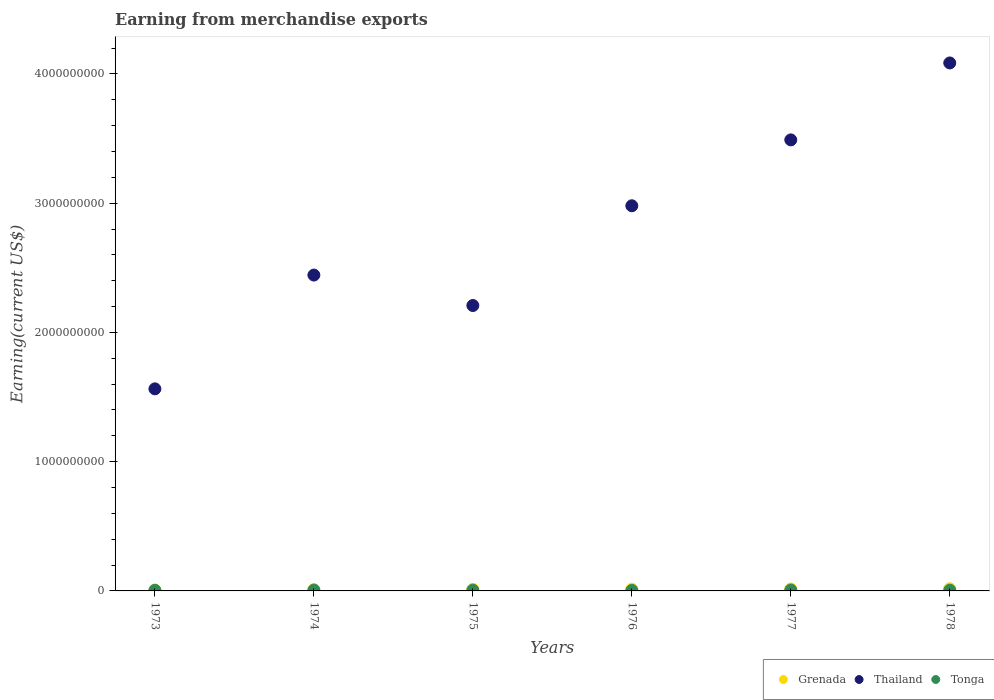How many different coloured dotlines are there?
Provide a short and direct response. 3. What is the amount earned from merchandise exports in Grenada in 1973?
Make the answer very short. 7.38e+06. Across all years, what is the maximum amount earned from merchandise exports in Grenada?
Give a very brief answer. 1.69e+07. Across all years, what is the minimum amount earned from merchandise exports in Grenada?
Provide a succinct answer. 7.38e+06. In which year was the amount earned from merchandise exports in Grenada maximum?
Keep it short and to the point. 1978. In which year was the amount earned from merchandise exports in Thailand minimum?
Your answer should be very brief. 1973. What is the total amount earned from merchandise exports in Grenada in the graph?
Give a very brief answer. 7.35e+07. What is the difference between the amount earned from merchandise exports in Tonga in 1976 and that in 1977?
Keep it short and to the point. -3.11e+06. What is the difference between the amount earned from merchandise exports in Tonga in 1973 and the amount earned from merchandise exports in Thailand in 1976?
Provide a short and direct response. -2.98e+09. What is the average amount earned from merchandise exports in Thailand per year?
Your answer should be very brief. 2.80e+09. In the year 1975, what is the difference between the amount earned from merchandise exports in Thailand and amount earned from merchandise exports in Grenada?
Your answer should be very brief. 2.20e+09. What is the ratio of the amount earned from merchandise exports in Tonga in 1975 to that in 1978?
Provide a succinct answer. 1.07. Is the difference between the amount earned from merchandise exports in Thailand in 1974 and 1976 greater than the difference between the amount earned from merchandise exports in Grenada in 1974 and 1976?
Provide a short and direct response. No. What is the difference between the highest and the second highest amount earned from merchandise exports in Thailand?
Give a very brief answer. 5.95e+08. What is the difference between the highest and the lowest amount earned from merchandise exports in Tonga?
Offer a very short reply. 3.11e+06. In how many years, is the amount earned from merchandise exports in Grenada greater than the average amount earned from merchandise exports in Grenada taken over all years?
Offer a very short reply. 4. Is it the case that in every year, the sum of the amount earned from merchandise exports in Grenada and amount earned from merchandise exports in Thailand  is greater than the amount earned from merchandise exports in Tonga?
Ensure brevity in your answer.  Yes. Does the amount earned from merchandise exports in Tonga monotonically increase over the years?
Offer a terse response. No. Is the amount earned from merchandise exports in Thailand strictly less than the amount earned from merchandise exports in Grenada over the years?
Provide a short and direct response. No. How many years are there in the graph?
Provide a succinct answer. 6. What is the difference between two consecutive major ticks on the Y-axis?
Your answer should be compact. 1.00e+09. Does the graph contain grids?
Offer a terse response. No. How are the legend labels stacked?
Ensure brevity in your answer.  Horizontal. What is the title of the graph?
Provide a succinct answer. Earning from merchandise exports. What is the label or title of the Y-axis?
Your answer should be very brief. Earning(current US$). What is the Earning(current US$) in Grenada in 1973?
Offer a very short reply. 7.38e+06. What is the Earning(current US$) of Thailand in 1973?
Your response must be concise. 1.56e+09. What is the Earning(current US$) in Tonga in 1973?
Keep it short and to the point. 4.54e+06. What is the Earning(current US$) of Grenada in 1974?
Provide a succinct answer. 9.50e+06. What is the Earning(current US$) of Thailand in 1974?
Keep it short and to the point. 2.44e+09. What is the Earning(current US$) in Tonga in 1974?
Ensure brevity in your answer.  6.61e+06. What is the Earning(current US$) in Grenada in 1975?
Your answer should be compact. 1.24e+07. What is the Earning(current US$) of Thailand in 1975?
Keep it short and to the point. 2.21e+09. What is the Earning(current US$) in Tonga in 1975?
Your answer should be very brief. 5.83e+06. What is the Earning(current US$) in Grenada in 1976?
Your response must be concise. 1.30e+07. What is the Earning(current US$) in Thailand in 1976?
Give a very brief answer. 2.98e+09. What is the Earning(current US$) in Tonga in 1976?
Keep it short and to the point. 3.93e+06. What is the Earning(current US$) in Grenada in 1977?
Ensure brevity in your answer.  1.44e+07. What is the Earning(current US$) in Thailand in 1977?
Give a very brief answer. 3.49e+09. What is the Earning(current US$) in Tonga in 1977?
Provide a short and direct response. 7.04e+06. What is the Earning(current US$) in Grenada in 1978?
Your answer should be compact. 1.69e+07. What is the Earning(current US$) of Thailand in 1978?
Provide a short and direct response. 4.09e+09. What is the Earning(current US$) in Tonga in 1978?
Offer a very short reply. 5.45e+06. Across all years, what is the maximum Earning(current US$) in Grenada?
Your response must be concise. 1.69e+07. Across all years, what is the maximum Earning(current US$) of Thailand?
Offer a very short reply. 4.09e+09. Across all years, what is the maximum Earning(current US$) of Tonga?
Ensure brevity in your answer.  7.04e+06. Across all years, what is the minimum Earning(current US$) of Grenada?
Offer a terse response. 7.38e+06. Across all years, what is the minimum Earning(current US$) of Thailand?
Provide a short and direct response. 1.56e+09. Across all years, what is the minimum Earning(current US$) of Tonga?
Your answer should be compact. 3.93e+06. What is the total Earning(current US$) of Grenada in the graph?
Provide a succinct answer. 7.35e+07. What is the total Earning(current US$) in Thailand in the graph?
Ensure brevity in your answer.  1.68e+1. What is the total Earning(current US$) of Tonga in the graph?
Keep it short and to the point. 3.34e+07. What is the difference between the Earning(current US$) of Grenada in 1973 and that in 1974?
Give a very brief answer. -2.12e+06. What is the difference between the Earning(current US$) in Thailand in 1973 and that in 1974?
Ensure brevity in your answer.  -8.80e+08. What is the difference between the Earning(current US$) in Tonga in 1973 and that in 1974?
Keep it short and to the point. -2.07e+06. What is the difference between the Earning(current US$) in Grenada in 1973 and that in 1975?
Your response must be concise. -5.02e+06. What is the difference between the Earning(current US$) in Thailand in 1973 and that in 1975?
Your answer should be very brief. -6.45e+08. What is the difference between the Earning(current US$) in Tonga in 1973 and that in 1975?
Provide a short and direct response. -1.28e+06. What is the difference between the Earning(current US$) of Grenada in 1973 and that in 1976?
Offer a very short reply. -5.58e+06. What is the difference between the Earning(current US$) in Thailand in 1973 and that in 1976?
Your response must be concise. -1.42e+09. What is the difference between the Earning(current US$) of Tonga in 1973 and that in 1976?
Offer a terse response. 6.11e+05. What is the difference between the Earning(current US$) of Grenada in 1973 and that in 1977?
Give a very brief answer. -6.97e+06. What is the difference between the Earning(current US$) of Thailand in 1973 and that in 1977?
Offer a terse response. -1.93e+09. What is the difference between the Earning(current US$) in Tonga in 1973 and that in 1977?
Your response must be concise. -2.50e+06. What is the difference between the Earning(current US$) of Grenada in 1973 and that in 1978?
Provide a short and direct response. -9.50e+06. What is the difference between the Earning(current US$) in Thailand in 1973 and that in 1978?
Offer a terse response. -2.52e+09. What is the difference between the Earning(current US$) of Tonga in 1973 and that in 1978?
Provide a short and direct response. -9.10e+05. What is the difference between the Earning(current US$) in Grenada in 1974 and that in 1975?
Your response must be concise. -2.90e+06. What is the difference between the Earning(current US$) of Thailand in 1974 and that in 1975?
Your answer should be very brief. 2.36e+08. What is the difference between the Earning(current US$) of Tonga in 1974 and that in 1975?
Your answer should be very brief. 7.84e+05. What is the difference between the Earning(current US$) of Grenada in 1974 and that in 1976?
Give a very brief answer. -3.46e+06. What is the difference between the Earning(current US$) in Thailand in 1974 and that in 1976?
Offer a terse response. -5.36e+08. What is the difference between the Earning(current US$) of Tonga in 1974 and that in 1976?
Give a very brief answer. 2.68e+06. What is the difference between the Earning(current US$) in Grenada in 1974 and that in 1977?
Keep it short and to the point. -4.85e+06. What is the difference between the Earning(current US$) in Thailand in 1974 and that in 1977?
Give a very brief answer. -1.05e+09. What is the difference between the Earning(current US$) in Tonga in 1974 and that in 1977?
Make the answer very short. -4.34e+05. What is the difference between the Earning(current US$) in Grenada in 1974 and that in 1978?
Keep it short and to the point. -7.38e+06. What is the difference between the Earning(current US$) in Thailand in 1974 and that in 1978?
Provide a short and direct response. -1.64e+09. What is the difference between the Earning(current US$) of Tonga in 1974 and that in 1978?
Your answer should be compact. 1.16e+06. What is the difference between the Earning(current US$) in Grenada in 1975 and that in 1976?
Offer a very short reply. -5.57e+05. What is the difference between the Earning(current US$) of Thailand in 1975 and that in 1976?
Provide a succinct answer. -7.72e+08. What is the difference between the Earning(current US$) in Tonga in 1975 and that in 1976?
Provide a succinct answer. 1.89e+06. What is the difference between the Earning(current US$) of Grenada in 1975 and that in 1977?
Provide a succinct answer. -1.95e+06. What is the difference between the Earning(current US$) in Thailand in 1975 and that in 1977?
Offer a terse response. -1.28e+09. What is the difference between the Earning(current US$) in Tonga in 1975 and that in 1977?
Offer a terse response. -1.22e+06. What is the difference between the Earning(current US$) of Grenada in 1975 and that in 1978?
Your answer should be compact. -4.48e+06. What is the difference between the Earning(current US$) of Thailand in 1975 and that in 1978?
Provide a succinct answer. -1.88e+09. What is the difference between the Earning(current US$) of Tonga in 1975 and that in 1978?
Your response must be concise. 3.72e+05. What is the difference between the Earning(current US$) in Grenada in 1976 and that in 1977?
Provide a short and direct response. -1.39e+06. What is the difference between the Earning(current US$) of Thailand in 1976 and that in 1977?
Offer a terse response. -5.10e+08. What is the difference between the Earning(current US$) of Tonga in 1976 and that in 1977?
Keep it short and to the point. -3.11e+06. What is the difference between the Earning(current US$) in Grenada in 1976 and that in 1978?
Keep it short and to the point. -3.92e+06. What is the difference between the Earning(current US$) in Thailand in 1976 and that in 1978?
Your answer should be compact. -1.11e+09. What is the difference between the Earning(current US$) in Tonga in 1976 and that in 1978?
Offer a terse response. -1.52e+06. What is the difference between the Earning(current US$) of Grenada in 1977 and that in 1978?
Offer a terse response. -2.53e+06. What is the difference between the Earning(current US$) in Thailand in 1977 and that in 1978?
Provide a succinct answer. -5.95e+08. What is the difference between the Earning(current US$) of Tonga in 1977 and that in 1978?
Provide a succinct answer. 1.59e+06. What is the difference between the Earning(current US$) in Grenada in 1973 and the Earning(current US$) in Thailand in 1974?
Your answer should be very brief. -2.44e+09. What is the difference between the Earning(current US$) in Grenada in 1973 and the Earning(current US$) in Tonga in 1974?
Your response must be concise. 7.72e+05. What is the difference between the Earning(current US$) of Thailand in 1973 and the Earning(current US$) of Tonga in 1974?
Give a very brief answer. 1.56e+09. What is the difference between the Earning(current US$) in Grenada in 1973 and the Earning(current US$) in Thailand in 1975?
Provide a succinct answer. -2.20e+09. What is the difference between the Earning(current US$) in Grenada in 1973 and the Earning(current US$) in Tonga in 1975?
Offer a very short reply. 1.56e+06. What is the difference between the Earning(current US$) of Thailand in 1973 and the Earning(current US$) of Tonga in 1975?
Offer a terse response. 1.56e+09. What is the difference between the Earning(current US$) in Grenada in 1973 and the Earning(current US$) in Thailand in 1976?
Give a very brief answer. -2.97e+09. What is the difference between the Earning(current US$) in Grenada in 1973 and the Earning(current US$) in Tonga in 1976?
Your answer should be very brief. 3.45e+06. What is the difference between the Earning(current US$) of Thailand in 1973 and the Earning(current US$) of Tonga in 1976?
Offer a very short reply. 1.56e+09. What is the difference between the Earning(current US$) in Grenada in 1973 and the Earning(current US$) in Thailand in 1977?
Provide a short and direct response. -3.48e+09. What is the difference between the Earning(current US$) of Grenada in 1973 and the Earning(current US$) of Tonga in 1977?
Your response must be concise. 3.38e+05. What is the difference between the Earning(current US$) of Thailand in 1973 and the Earning(current US$) of Tonga in 1977?
Make the answer very short. 1.56e+09. What is the difference between the Earning(current US$) in Grenada in 1973 and the Earning(current US$) in Thailand in 1978?
Offer a very short reply. -4.08e+09. What is the difference between the Earning(current US$) of Grenada in 1973 and the Earning(current US$) of Tonga in 1978?
Ensure brevity in your answer.  1.93e+06. What is the difference between the Earning(current US$) of Thailand in 1973 and the Earning(current US$) of Tonga in 1978?
Keep it short and to the point. 1.56e+09. What is the difference between the Earning(current US$) of Grenada in 1974 and the Earning(current US$) of Thailand in 1975?
Offer a very short reply. -2.20e+09. What is the difference between the Earning(current US$) in Grenada in 1974 and the Earning(current US$) in Tonga in 1975?
Your answer should be compact. 3.68e+06. What is the difference between the Earning(current US$) in Thailand in 1974 and the Earning(current US$) in Tonga in 1975?
Your answer should be compact. 2.44e+09. What is the difference between the Earning(current US$) in Grenada in 1974 and the Earning(current US$) in Thailand in 1976?
Your response must be concise. -2.97e+09. What is the difference between the Earning(current US$) of Grenada in 1974 and the Earning(current US$) of Tonga in 1976?
Offer a very short reply. 5.57e+06. What is the difference between the Earning(current US$) of Thailand in 1974 and the Earning(current US$) of Tonga in 1976?
Keep it short and to the point. 2.44e+09. What is the difference between the Earning(current US$) in Grenada in 1974 and the Earning(current US$) in Thailand in 1977?
Provide a short and direct response. -3.48e+09. What is the difference between the Earning(current US$) of Grenada in 1974 and the Earning(current US$) of Tonga in 1977?
Provide a short and direct response. 2.46e+06. What is the difference between the Earning(current US$) of Thailand in 1974 and the Earning(current US$) of Tonga in 1977?
Your response must be concise. 2.44e+09. What is the difference between the Earning(current US$) in Grenada in 1974 and the Earning(current US$) in Thailand in 1978?
Make the answer very short. -4.08e+09. What is the difference between the Earning(current US$) in Grenada in 1974 and the Earning(current US$) in Tonga in 1978?
Provide a succinct answer. 4.05e+06. What is the difference between the Earning(current US$) in Thailand in 1974 and the Earning(current US$) in Tonga in 1978?
Your response must be concise. 2.44e+09. What is the difference between the Earning(current US$) of Grenada in 1975 and the Earning(current US$) of Thailand in 1976?
Offer a terse response. -2.97e+09. What is the difference between the Earning(current US$) of Grenada in 1975 and the Earning(current US$) of Tonga in 1976?
Your answer should be compact. 8.47e+06. What is the difference between the Earning(current US$) in Thailand in 1975 and the Earning(current US$) in Tonga in 1976?
Ensure brevity in your answer.  2.20e+09. What is the difference between the Earning(current US$) in Grenada in 1975 and the Earning(current US$) in Thailand in 1977?
Your answer should be very brief. -3.48e+09. What is the difference between the Earning(current US$) in Grenada in 1975 and the Earning(current US$) in Tonga in 1977?
Provide a succinct answer. 5.36e+06. What is the difference between the Earning(current US$) of Thailand in 1975 and the Earning(current US$) of Tonga in 1977?
Make the answer very short. 2.20e+09. What is the difference between the Earning(current US$) in Grenada in 1975 and the Earning(current US$) in Thailand in 1978?
Provide a short and direct response. -4.07e+09. What is the difference between the Earning(current US$) of Grenada in 1975 and the Earning(current US$) of Tonga in 1978?
Provide a short and direct response. 6.95e+06. What is the difference between the Earning(current US$) in Thailand in 1975 and the Earning(current US$) in Tonga in 1978?
Provide a short and direct response. 2.20e+09. What is the difference between the Earning(current US$) in Grenada in 1976 and the Earning(current US$) in Thailand in 1977?
Keep it short and to the point. -3.48e+09. What is the difference between the Earning(current US$) of Grenada in 1976 and the Earning(current US$) of Tonga in 1977?
Provide a short and direct response. 5.92e+06. What is the difference between the Earning(current US$) in Thailand in 1976 and the Earning(current US$) in Tonga in 1977?
Your answer should be compact. 2.97e+09. What is the difference between the Earning(current US$) in Grenada in 1976 and the Earning(current US$) in Thailand in 1978?
Provide a short and direct response. -4.07e+09. What is the difference between the Earning(current US$) in Grenada in 1976 and the Earning(current US$) in Tonga in 1978?
Ensure brevity in your answer.  7.51e+06. What is the difference between the Earning(current US$) in Thailand in 1976 and the Earning(current US$) in Tonga in 1978?
Your response must be concise. 2.97e+09. What is the difference between the Earning(current US$) in Grenada in 1977 and the Earning(current US$) in Thailand in 1978?
Provide a succinct answer. -4.07e+09. What is the difference between the Earning(current US$) of Grenada in 1977 and the Earning(current US$) of Tonga in 1978?
Offer a very short reply. 8.90e+06. What is the difference between the Earning(current US$) of Thailand in 1977 and the Earning(current US$) of Tonga in 1978?
Your response must be concise. 3.48e+09. What is the average Earning(current US$) of Grenada per year?
Your answer should be compact. 1.22e+07. What is the average Earning(current US$) of Thailand per year?
Offer a terse response. 2.80e+09. What is the average Earning(current US$) of Tonga per year?
Make the answer very short. 5.57e+06. In the year 1973, what is the difference between the Earning(current US$) of Grenada and Earning(current US$) of Thailand?
Offer a terse response. -1.56e+09. In the year 1973, what is the difference between the Earning(current US$) in Grenada and Earning(current US$) in Tonga?
Give a very brief answer. 2.84e+06. In the year 1973, what is the difference between the Earning(current US$) of Thailand and Earning(current US$) of Tonga?
Give a very brief answer. 1.56e+09. In the year 1974, what is the difference between the Earning(current US$) of Grenada and Earning(current US$) of Thailand?
Provide a succinct answer. -2.43e+09. In the year 1974, what is the difference between the Earning(current US$) of Grenada and Earning(current US$) of Tonga?
Give a very brief answer. 2.89e+06. In the year 1974, what is the difference between the Earning(current US$) in Thailand and Earning(current US$) in Tonga?
Provide a succinct answer. 2.44e+09. In the year 1975, what is the difference between the Earning(current US$) of Grenada and Earning(current US$) of Thailand?
Give a very brief answer. -2.20e+09. In the year 1975, what is the difference between the Earning(current US$) in Grenada and Earning(current US$) in Tonga?
Offer a terse response. 6.58e+06. In the year 1975, what is the difference between the Earning(current US$) of Thailand and Earning(current US$) of Tonga?
Offer a terse response. 2.20e+09. In the year 1976, what is the difference between the Earning(current US$) of Grenada and Earning(current US$) of Thailand?
Your response must be concise. -2.97e+09. In the year 1976, what is the difference between the Earning(current US$) of Grenada and Earning(current US$) of Tonga?
Provide a succinct answer. 9.03e+06. In the year 1976, what is the difference between the Earning(current US$) of Thailand and Earning(current US$) of Tonga?
Keep it short and to the point. 2.98e+09. In the year 1977, what is the difference between the Earning(current US$) of Grenada and Earning(current US$) of Thailand?
Offer a very short reply. -3.48e+09. In the year 1977, what is the difference between the Earning(current US$) of Grenada and Earning(current US$) of Tonga?
Make the answer very short. 7.31e+06. In the year 1977, what is the difference between the Earning(current US$) of Thailand and Earning(current US$) of Tonga?
Your answer should be very brief. 3.48e+09. In the year 1978, what is the difference between the Earning(current US$) in Grenada and Earning(current US$) in Thailand?
Give a very brief answer. -4.07e+09. In the year 1978, what is the difference between the Earning(current US$) of Grenada and Earning(current US$) of Tonga?
Keep it short and to the point. 1.14e+07. In the year 1978, what is the difference between the Earning(current US$) of Thailand and Earning(current US$) of Tonga?
Make the answer very short. 4.08e+09. What is the ratio of the Earning(current US$) in Grenada in 1973 to that in 1974?
Provide a succinct answer. 0.78. What is the ratio of the Earning(current US$) of Thailand in 1973 to that in 1974?
Provide a short and direct response. 0.64. What is the ratio of the Earning(current US$) in Tonga in 1973 to that in 1974?
Ensure brevity in your answer.  0.69. What is the ratio of the Earning(current US$) in Grenada in 1973 to that in 1975?
Offer a terse response. 0.6. What is the ratio of the Earning(current US$) in Thailand in 1973 to that in 1975?
Offer a very short reply. 0.71. What is the ratio of the Earning(current US$) in Tonga in 1973 to that in 1975?
Offer a very short reply. 0.78. What is the ratio of the Earning(current US$) in Grenada in 1973 to that in 1976?
Make the answer very short. 0.57. What is the ratio of the Earning(current US$) of Thailand in 1973 to that in 1976?
Your response must be concise. 0.52. What is the ratio of the Earning(current US$) in Tonga in 1973 to that in 1976?
Your answer should be compact. 1.16. What is the ratio of the Earning(current US$) in Grenada in 1973 to that in 1977?
Provide a succinct answer. 0.51. What is the ratio of the Earning(current US$) in Thailand in 1973 to that in 1977?
Provide a short and direct response. 0.45. What is the ratio of the Earning(current US$) of Tonga in 1973 to that in 1977?
Offer a terse response. 0.65. What is the ratio of the Earning(current US$) in Grenada in 1973 to that in 1978?
Give a very brief answer. 0.44. What is the ratio of the Earning(current US$) of Thailand in 1973 to that in 1978?
Ensure brevity in your answer.  0.38. What is the ratio of the Earning(current US$) in Tonga in 1973 to that in 1978?
Your answer should be compact. 0.83. What is the ratio of the Earning(current US$) of Grenada in 1974 to that in 1975?
Keep it short and to the point. 0.77. What is the ratio of the Earning(current US$) of Thailand in 1974 to that in 1975?
Ensure brevity in your answer.  1.11. What is the ratio of the Earning(current US$) in Tonga in 1974 to that in 1975?
Provide a short and direct response. 1.13. What is the ratio of the Earning(current US$) of Grenada in 1974 to that in 1976?
Your response must be concise. 0.73. What is the ratio of the Earning(current US$) of Thailand in 1974 to that in 1976?
Your answer should be compact. 0.82. What is the ratio of the Earning(current US$) of Tonga in 1974 to that in 1976?
Provide a short and direct response. 1.68. What is the ratio of the Earning(current US$) of Grenada in 1974 to that in 1977?
Ensure brevity in your answer.  0.66. What is the ratio of the Earning(current US$) in Thailand in 1974 to that in 1977?
Make the answer very short. 0.7. What is the ratio of the Earning(current US$) of Tonga in 1974 to that in 1977?
Give a very brief answer. 0.94. What is the ratio of the Earning(current US$) of Grenada in 1974 to that in 1978?
Offer a terse response. 0.56. What is the ratio of the Earning(current US$) in Thailand in 1974 to that in 1978?
Offer a very short reply. 0.6. What is the ratio of the Earning(current US$) of Tonga in 1974 to that in 1978?
Offer a very short reply. 1.21. What is the ratio of the Earning(current US$) of Grenada in 1975 to that in 1976?
Provide a succinct answer. 0.96. What is the ratio of the Earning(current US$) in Thailand in 1975 to that in 1976?
Offer a very short reply. 0.74. What is the ratio of the Earning(current US$) in Tonga in 1975 to that in 1976?
Your answer should be compact. 1.48. What is the ratio of the Earning(current US$) in Grenada in 1975 to that in 1977?
Keep it short and to the point. 0.86. What is the ratio of the Earning(current US$) in Thailand in 1975 to that in 1977?
Offer a terse response. 0.63. What is the ratio of the Earning(current US$) in Tonga in 1975 to that in 1977?
Provide a succinct answer. 0.83. What is the ratio of the Earning(current US$) in Grenada in 1975 to that in 1978?
Ensure brevity in your answer.  0.73. What is the ratio of the Earning(current US$) of Thailand in 1975 to that in 1978?
Make the answer very short. 0.54. What is the ratio of the Earning(current US$) in Tonga in 1975 to that in 1978?
Your answer should be very brief. 1.07. What is the ratio of the Earning(current US$) in Grenada in 1976 to that in 1977?
Your answer should be very brief. 0.9. What is the ratio of the Earning(current US$) of Thailand in 1976 to that in 1977?
Offer a terse response. 0.85. What is the ratio of the Earning(current US$) in Tonga in 1976 to that in 1977?
Keep it short and to the point. 0.56. What is the ratio of the Earning(current US$) in Grenada in 1976 to that in 1978?
Your answer should be compact. 0.77. What is the ratio of the Earning(current US$) of Thailand in 1976 to that in 1978?
Make the answer very short. 0.73. What is the ratio of the Earning(current US$) in Tonga in 1976 to that in 1978?
Your answer should be compact. 0.72. What is the ratio of the Earning(current US$) in Grenada in 1977 to that in 1978?
Keep it short and to the point. 0.85. What is the ratio of the Earning(current US$) of Thailand in 1977 to that in 1978?
Provide a succinct answer. 0.85. What is the ratio of the Earning(current US$) of Tonga in 1977 to that in 1978?
Offer a terse response. 1.29. What is the difference between the highest and the second highest Earning(current US$) of Grenada?
Offer a very short reply. 2.53e+06. What is the difference between the highest and the second highest Earning(current US$) of Thailand?
Provide a succinct answer. 5.95e+08. What is the difference between the highest and the second highest Earning(current US$) in Tonga?
Your response must be concise. 4.34e+05. What is the difference between the highest and the lowest Earning(current US$) of Grenada?
Keep it short and to the point. 9.50e+06. What is the difference between the highest and the lowest Earning(current US$) in Thailand?
Provide a short and direct response. 2.52e+09. What is the difference between the highest and the lowest Earning(current US$) in Tonga?
Give a very brief answer. 3.11e+06. 